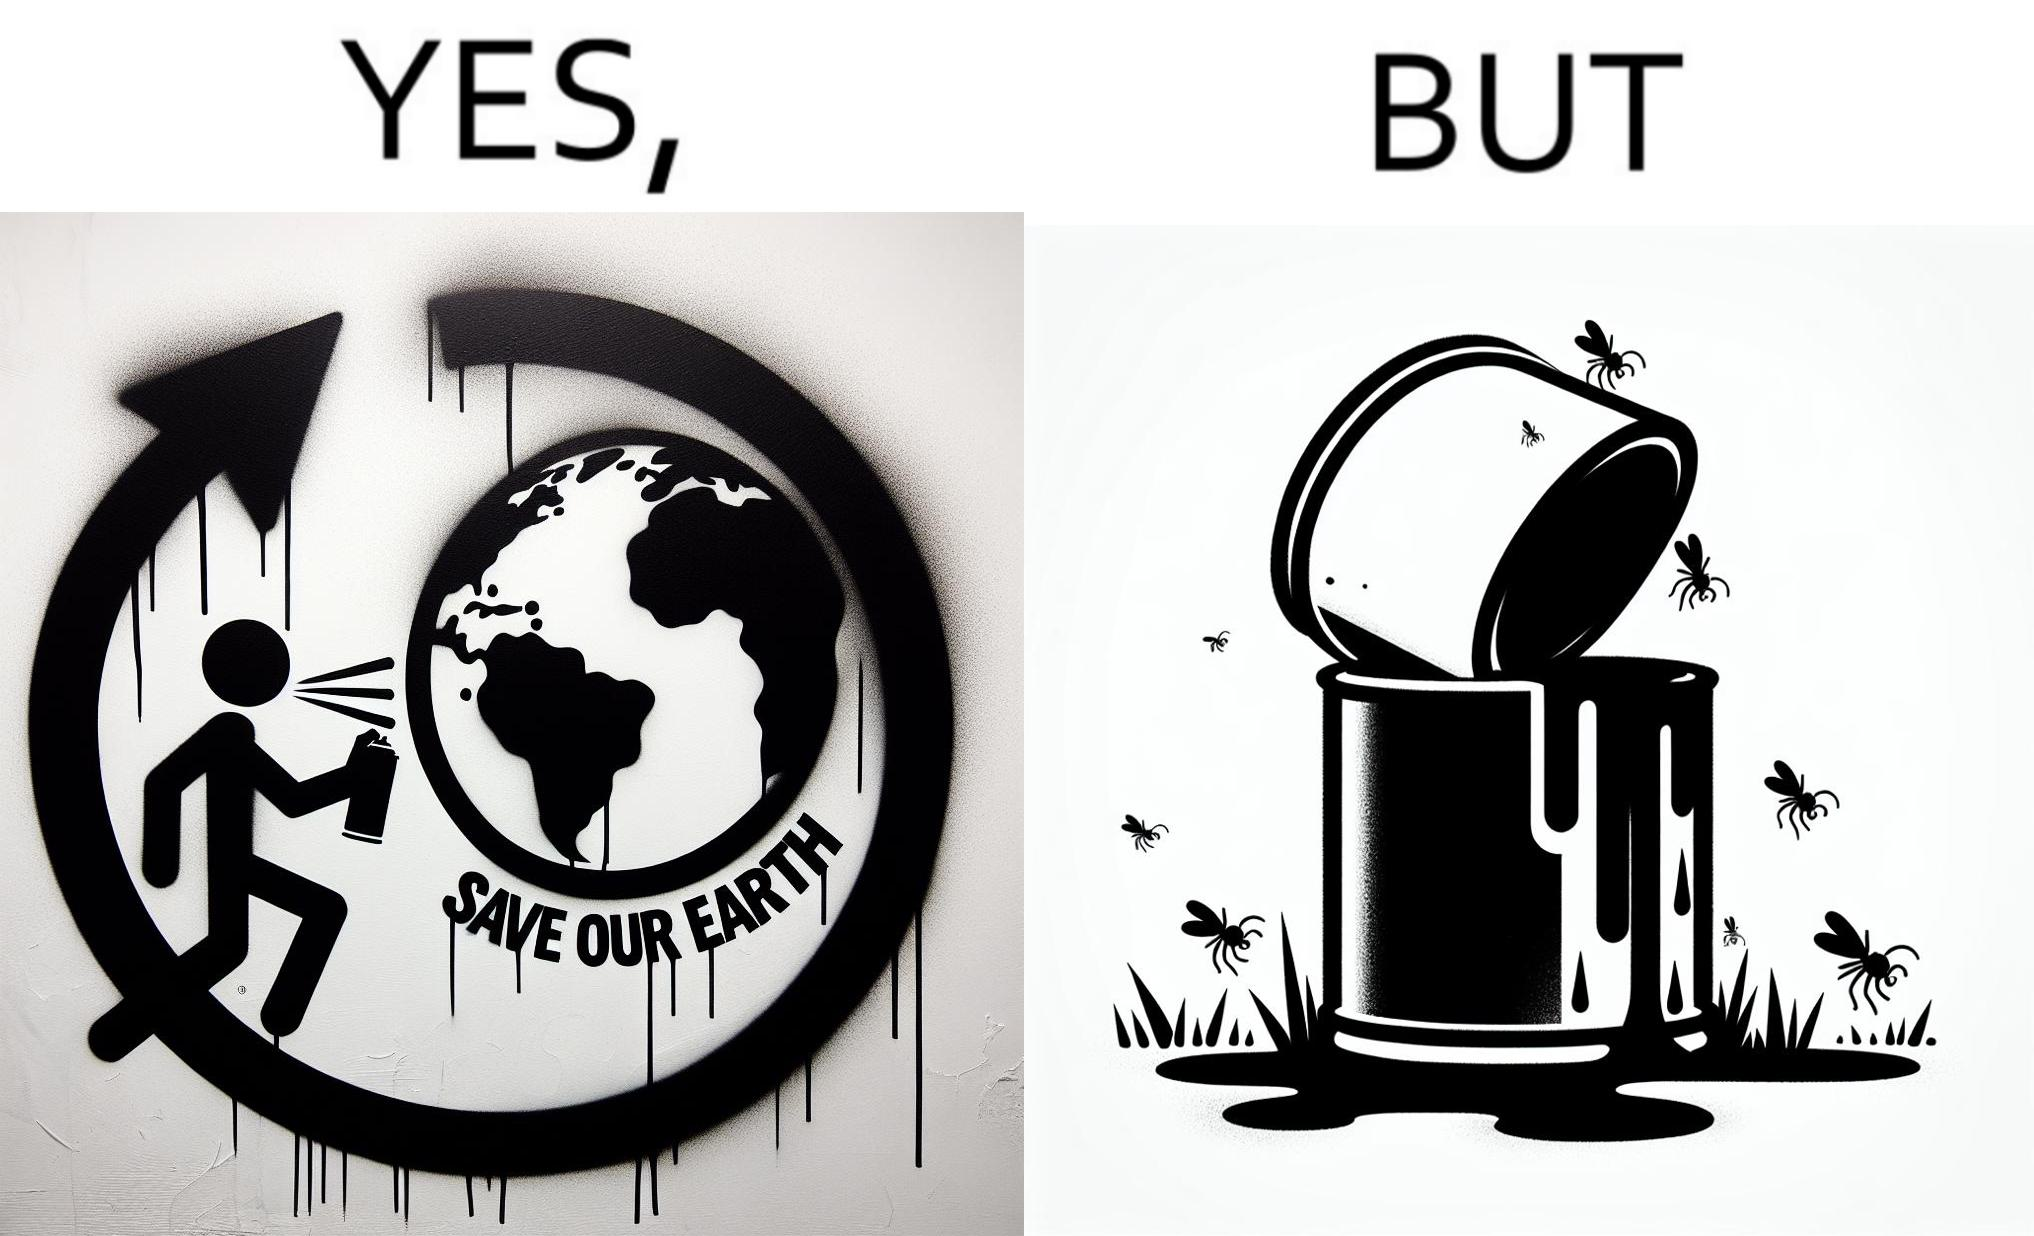Is this a satirical image? Yes, this image is satirical. 